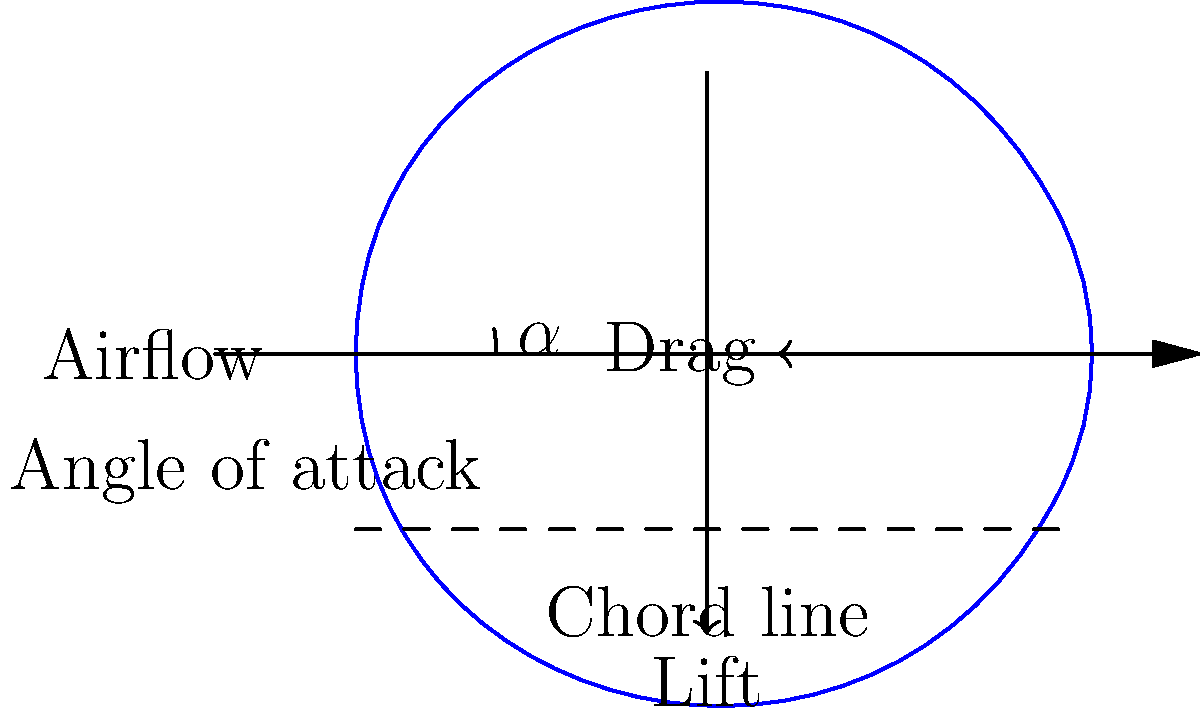In the ethereal dance of air and wing, where dreams take flight,
Which force, like a muse's whisper, lifts the airfoil's plight?
And what earthly tether, a reluctant embrace so tight,
Opposes motion, a counterpoint to aerial delight? To understand the forces acting on an airfoil in subsonic flow, let's break it down step-by-step:

1. Lift Force:
   - As air flows over the airfoil, it creates a pressure difference between the upper and lower surfaces.
   - The curved upper surface causes air to move faster, creating lower pressure.
   - The flatter lower surface has higher pressure.
   - This pressure difference results in an upward force called lift.
   - Lift is perpendicular to the oncoming airflow.

2. Drag Force:
   - Drag is the force that opposes the motion of the airfoil through the air.
   - It is parallel to the direction of the airflow.
   - Drag is composed of two main components:
     a) Friction drag: due to the viscosity of air moving over the airfoil surface.
     b) Pressure drag: caused by the difference in pressure between the front and back of the airfoil.

3. Angle of Attack:
   - The angle between the chord line of the airfoil and the direction of the oncoming air flow is called the angle of attack ($\alpha$).
   - As the angle of attack increases (within limits), both lift and drag increase.

4. Lift Coefficient:
   - The lift force is often expressed using the lift coefficient ($C_L$):
     $$ L = \frac{1}{2} \rho v^2 S C_L $$
   Where $L$ is lift, $\rho$ is air density, $v$ is airspeed, and $S$ is wing area.

5. Drag Coefficient:
   - Similarly, drag is expressed using the drag coefficient ($C_D$):
     $$ D = \frac{1}{2} \rho v^2 S C_D $$
   Where $D$ is drag.

In the context of the poetic question, the "muse's whisper" that lifts the airfoil is the lift force, while the "earthly tether" that opposes motion is the drag force.
Answer: Lift and drag 